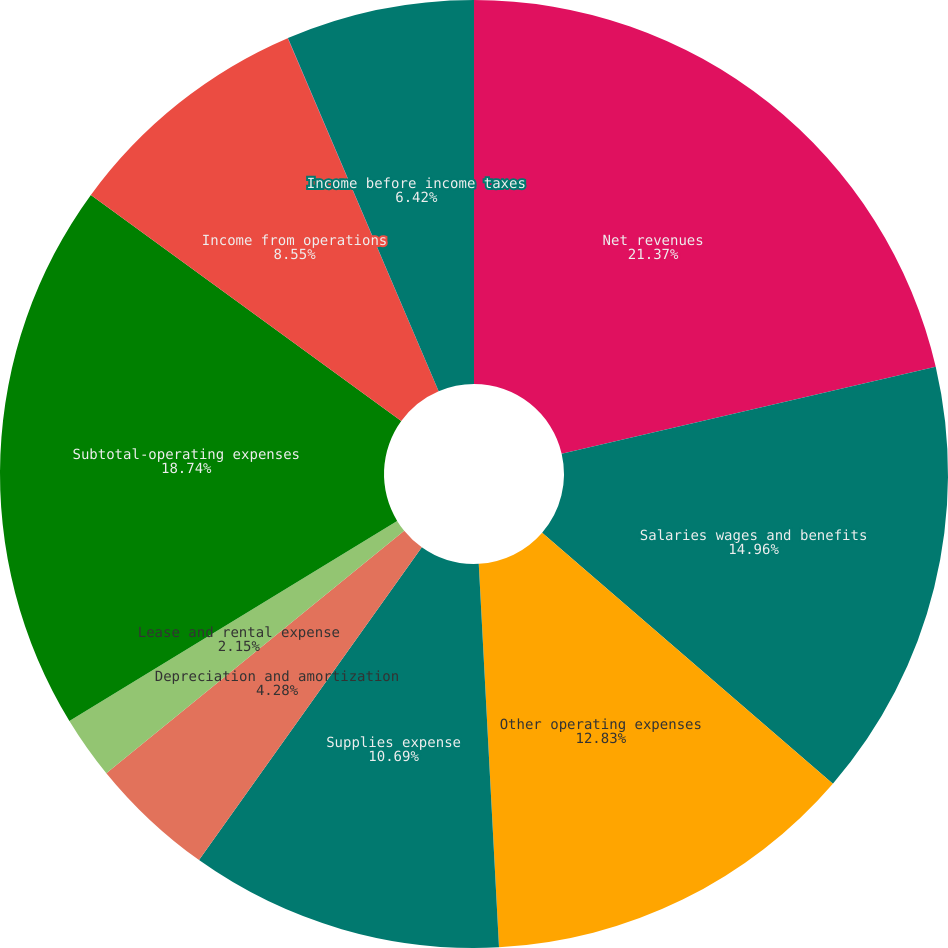<chart> <loc_0><loc_0><loc_500><loc_500><pie_chart><fcel>Net revenues<fcel>Salaries wages and benefits<fcel>Other operating expenses<fcel>Supplies expense<fcel>Depreciation and amortization<fcel>Lease and rental expense<fcel>Subtotal-operating expenses<fcel>Income from operations<fcel>Interest expense net<fcel>Income before income taxes<nl><fcel>21.37%<fcel>14.96%<fcel>12.83%<fcel>10.69%<fcel>4.28%<fcel>2.15%<fcel>18.74%<fcel>8.55%<fcel>0.01%<fcel>6.42%<nl></chart> 